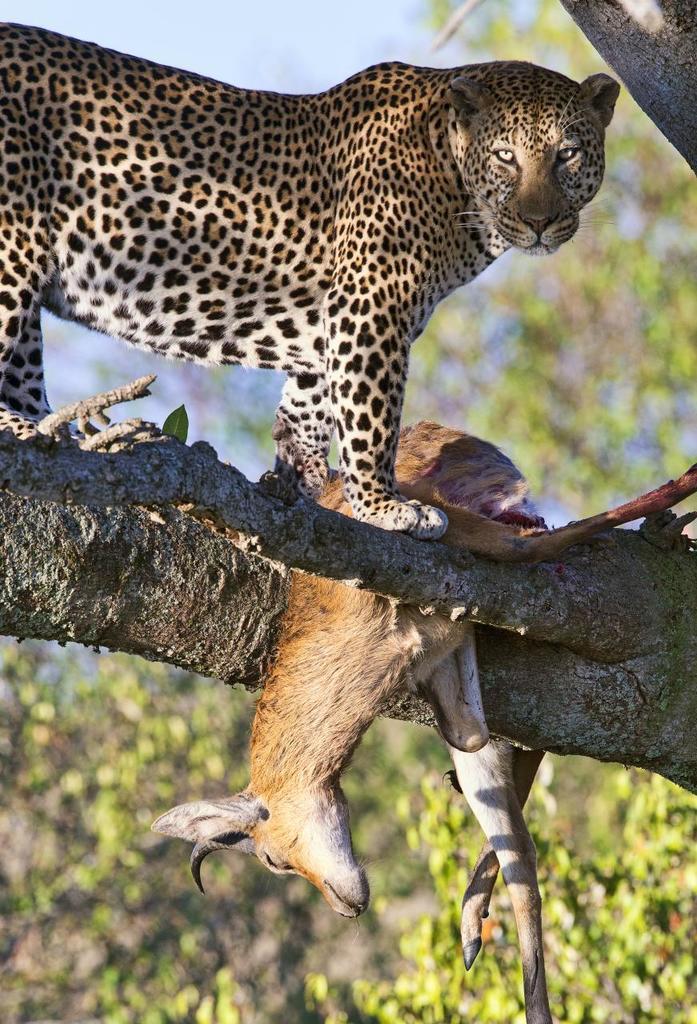Can you describe this image briefly? In this picture we can see a leopard and a deer on the tree, in the background we can find few more trees. 